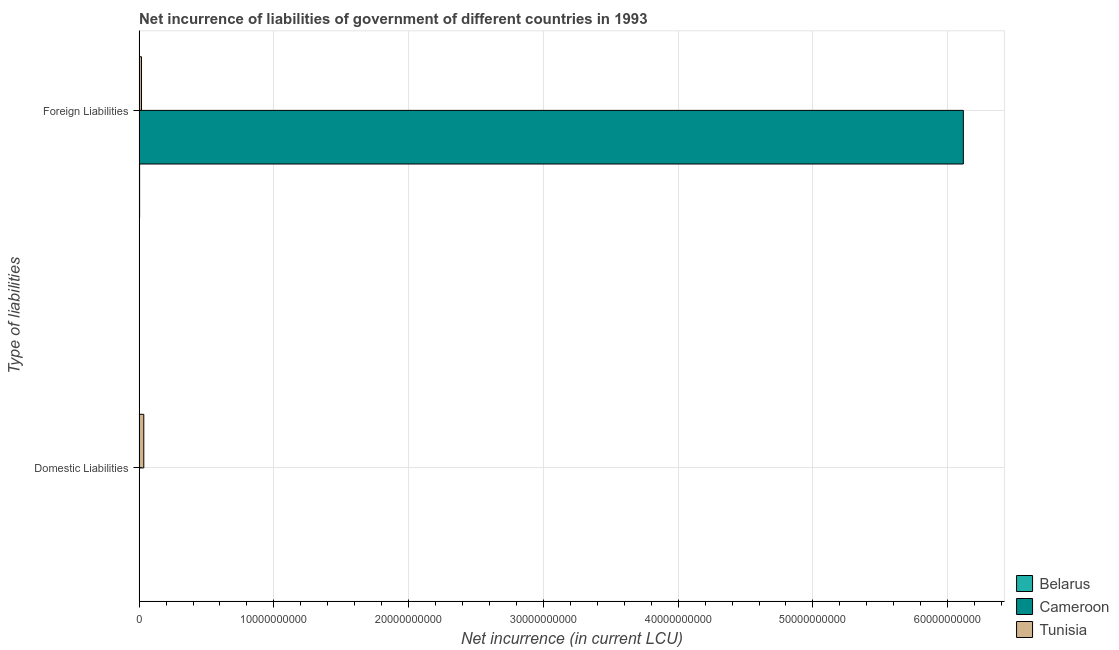How many bars are there on the 1st tick from the bottom?
Provide a succinct answer. 2. What is the label of the 1st group of bars from the top?
Provide a succinct answer. Foreign Liabilities. What is the net incurrence of domestic liabilities in Belarus?
Keep it short and to the point. 1.02e+07. Across all countries, what is the maximum net incurrence of domestic liabilities?
Give a very brief answer. 3.48e+08. Across all countries, what is the minimum net incurrence of domestic liabilities?
Keep it short and to the point. 0. In which country was the net incurrence of foreign liabilities maximum?
Give a very brief answer. Cameroon. What is the total net incurrence of domestic liabilities in the graph?
Provide a short and direct response. 3.59e+08. What is the difference between the net incurrence of foreign liabilities in Cameroon and that in Tunisia?
Provide a short and direct response. 6.10e+1. What is the difference between the net incurrence of domestic liabilities in Belarus and the net incurrence of foreign liabilities in Tunisia?
Ensure brevity in your answer.  -1.65e+08. What is the average net incurrence of domestic liabilities per country?
Make the answer very short. 1.20e+08. What is the difference between the net incurrence of foreign liabilities and net incurrence of domestic liabilities in Belarus?
Keep it short and to the point. 2.80e+07. In how many countries, is the net incurrence of domestic liabilities greater than 36000000000 LCU?
Offer a terse response. 0. What is the ratio of the net incurrence of domestic liabilities in Belarus to that in Tunisia?
Provide a succinct answer. 0.03. In how many countries, is the net incurrence of foreign liabilities greater than the average net incurrence of foreign liabilities taken over all countries?
Keep it short and to the point. 1. How many bars are there?
Provide a short and direct response. 5. Are all the bars in the graph horizontal?
Offer a very short reply. Yes. Where does the legend appear in the graph?
Your answer should be very brief. Bottom right. What is the title of the graph?
Your response must be concise. Net incurrence of liabilities of government of different countries in 1993. Does "Saudi Arabia" appear as one of the legend labels in the graph?
Your answer should be very brief. No. What is the label or title of the X-axis?
Offer a very short reply. Net incurrence (in current LCU). What is the label or title of the Y-axis?
Provide a short and direct response. Type of liabilities. What is the Net incurrence (in current LCU) in Belarus in Domestic Liabilities?
Keep it short and to the point. 1.02e+07. What is the Net incurrence (in current LCU) in Cameroon in Domestic Liabilities?
Provide a succinct answer. 0. What is the Net incurrence (in current LCU) of Tunisia in Domestic Liabilities?
Give a very brief answer. 3.48e+08. What is the Net incurrence (in current LCU) in Belarus in Foreign Liabilities?
Provide a succinct answer. 3.82e+07. What is the Net incurrence (in current LCU) of Cameroon in Foreign Liabilities?
Offer a terse response. 6.12e+1. What is the Net incurrence (in current LCU) of Tunisia in Foreign Liabilities?
Offer a terse response. 1.75e+08. Across all Type of liabilities, what is the maximum Net incurrence (in current LCU) in Belarus?
Offer a terse response. 3.82e+07. Across all Type of liabilities, what is the maximum Net incurrence (in current LCU) of Cameroon?
Your response must be concise. 6.12e+1. Across all Type of liabilities, what is the maximum Net incurrence (in current LCU) of Tunisia?
Ensure brevity in your answer.  3.48e+08. Across all Type of liabilities, what is the minimum Net incurrence (in current LCU) of Belarus?
Provide a succinct answer. 1.02e+07. Across all Type of liabilities, what is the minimum Net incurrence (in current LCU) in Cameroon?
Make the answer very short. 0. Across all Type of liabilities, what is the minimum Net incurrence (in current LCU) of Tunisia?
Your answer should be compact. 1.75e+08. What is the total Net incurrence (in current LCU) of Belarus in the graph?
Offer a very short reply. 4.84e+07. What is the total Net incurrence (in current LCU) of Cameroon in the graph?
Give a very brief answer. 6.12e+1. What is the total Net incurrence (in current LCU) of Tunisia in the graph?
Keep it short and to the point. 5.24e+08. What is the difference between the Net incurrence (in current LCU) in Belarus in Domestic Liabilities and that in Foreign Liabilities?
Give a very brief answer. -2.80e+07. What is the difference between the Net incurrence (in current LCU) of Tunisia in Domestic Liabilities and that in Foreign Liabilities?
Make the answer very short. 1.73e+08. What is the difference between the Net incurrence (in current LCU) of Belarus in Domestic Liabilities and the Net incurrence (in current LCU) of Cameroon in Foreign Liabilities?
Provide a succinct answer. -6.11e+1. What is the difference between the Net incurrence (in current LCU) in Belarus in Domestic Liabilities and the Net incurrence (in current LCU) in Tunisia in Foreign Liabilities?
Make the answer very short. -1.65e+08. What is the average Net incurrence (in current LCU) in Belarus per Type of liabilities?
Make the answer very short. 2.42e+07. What is the average Net incurrence (in current LCU) of Cameroon per Type of liabilities?
Ensure brevity in your answer.  3.06e+1. What is the average Net incurrence (in current LCU) in Tunisia per Type of liabilities?
Provide a succinct answer. 2.62e+08. What is the difference between the Net incurrence (in current LCU) of Belarus and Net incurrence (in current LCU) of Tunisia in Domestic Liabilities?
Your answer should be very brief. -3.38e+08. What is the difference between the Net incurrence (in current LCU) of Belarus and Net incurrence (in current LCU) of Cameroon in Foreign Liabilities?
Your response must be concise. -6.11e+1. What is the difference between the Net incurrence (in current LCU) in Belarus and Net incurrence (in current LCU) in Tunisia in Foreign Liabilities?
Provide a short and direct response. -1.37e+08. What is the difference between the Net incurrence (in current LCU) in Cameroon and Net incurrence (in current LCU) in Tunisia in Foreign Liabilities?
Provide a succinct answer. 6.10e+1. What is the ratio of the Net incurrence (in current LCU) of Belarus in Domestic Liabilities to that in Foreign Liabilities?
Your answer should be compact. 0.27. What is the ratio of the Net incurrence (in current LCU) in Tunisia in Domestic Liabilities to that in Foreign Liabilities?
Your response must be concise. 1.99. What is the difference between the highest and the second highest Net incurrence (in current LCU) of Belarus?
Offer a very short reply. 2.80e+07. What is the difference between the highest and the second highest Net incurrence (in current LCU) in Tunisia?
Offer a terse response. 1.73e+08. What is the difference between the highest and the lowest Net incurrence (in current LCU) of Belarus?
Provide a short and direct response. 2.80e+07. What is the difference between the highest and the lowest Net incurrence (in current LCU) of Cameroon?
Your answer should be compact. 6.12e+1. What is the difference between the highest and the lowest Net incurrence (in current LCU) of Tunisia?
Offer a very short reply. 1.73e+08. 